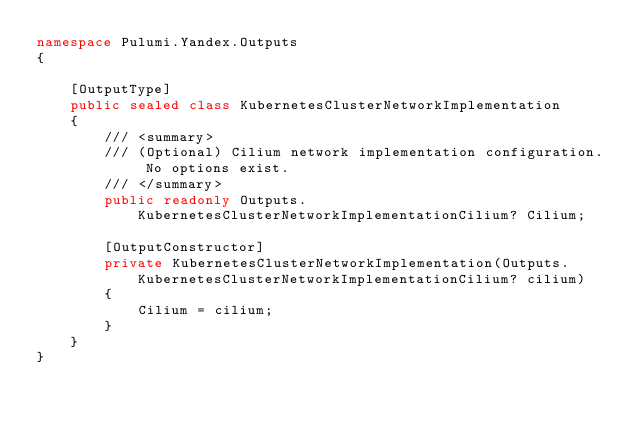<code> <loc_0><loc_0><loc_500><loc_500><_C#_>namespace Pulumi.Yandex.Outputs
{

    [OutputType]
    public sealed class KubernetesClusterNetworkImplementation
    {
        /// <summary>
        /// (Optional) Cilium network implementation configuration. No options exist.
        /// </summary>
        public readonly Outputs.KubernetesClusterNetworkImplementationCilium? Cilium;

        [OutputConstructor]
        private KubernetesClusterNetworkImplementation(Outputs.KubernetesClusterNetworkImplementationCilium? cilium)
        {
            Cilium = cilium;
        }
    }
}
</code> 